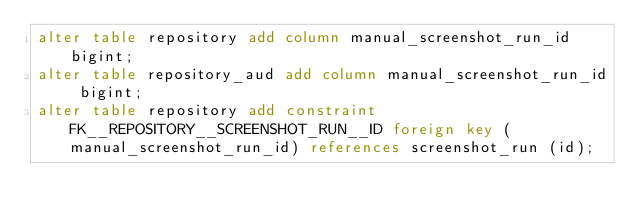<code> <loc_0><loc_0><loc_500><loc_500><_SQL_>alter table repository add column manual_screenshot_run_id bigint;
alter table repository_aud add column manual_screenshot_run_id bigint;
alter table repository add constraint FK__REPOSITORY__SCREENSHOT_RUN__ID foreign key (manual_screenshot_run_id) references screenshot_run (id);
</code> 